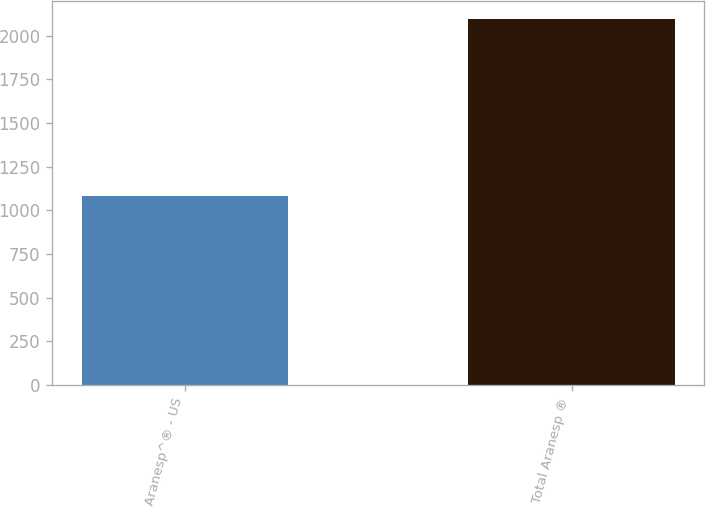Convert chart. <chart><loc_0><loc_0><loc_500><loc_500><bar_chart><fcel>Aranesp^® - US<fcel>Total Aranesp ®<nl><fcel>1082<fcel>2093<nl></chart> 